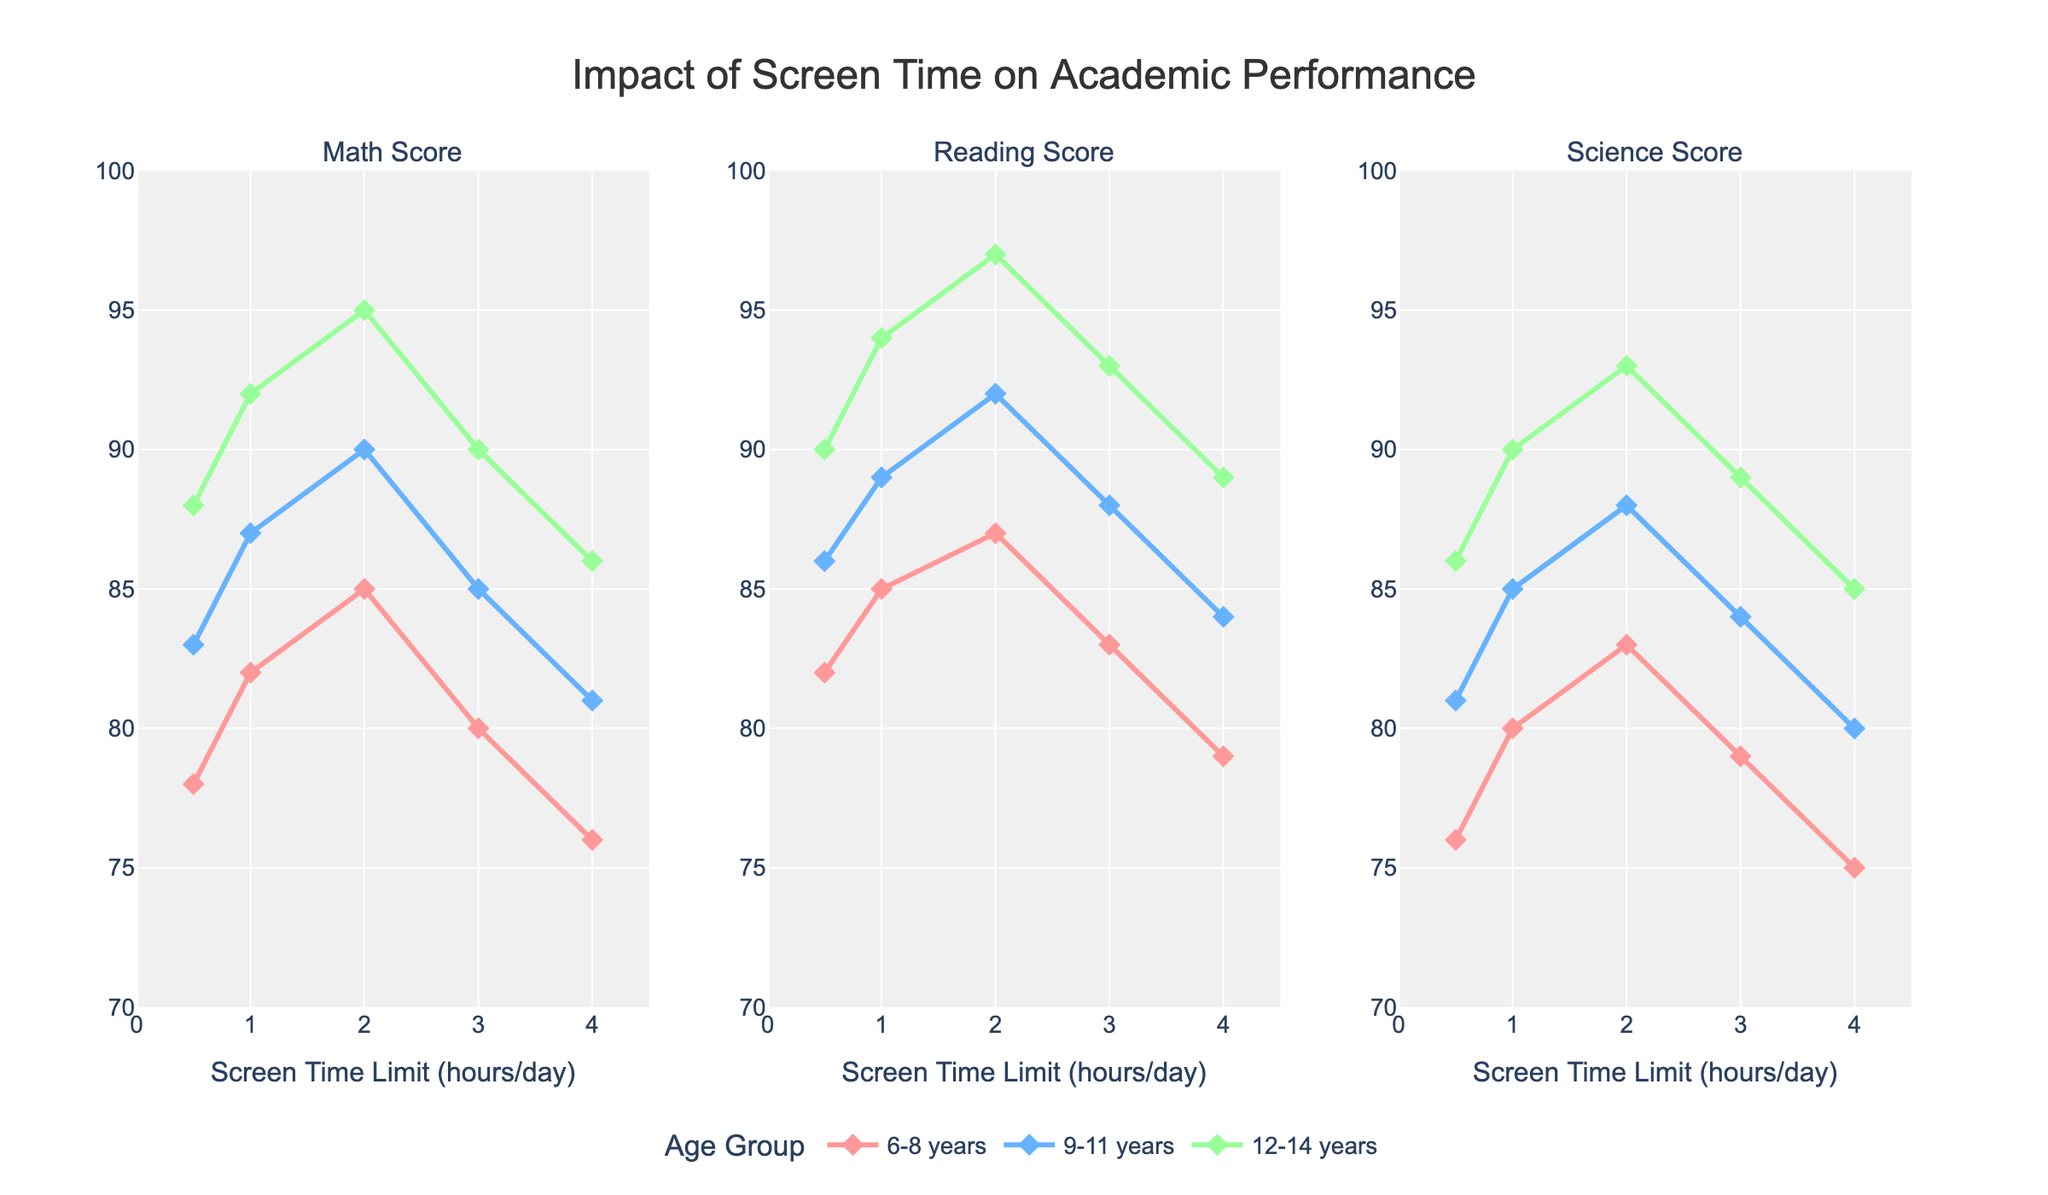What is the title of the figure? The title is located at the top of the figure and is clearly visible. It reads "Impact of Screen Time on Academic Performance."
Answer: Impact of Screen Time on Academic Performance How many age groups are represented in the figure? By observing the legend on the figure, three distinct age groups can be identified.
Answer: Three What trend do you observe in the Math Scores for 6-8-year-olds as screen time increases? By following the line plot for 6-8-year-olds, it can be seen that the Math Scores initially increase with screen time up to 2 hours and then start to decline.
Answer: Initially increase then decline Which age group consistently has the highest scores across all subjects? Looking at the y-values for each age group across the three subplots, the 12-14-year-olds (represented by green) consistently have the highest scores in Math, Reading, and Science.
Answer: 12-14 years What is the Reading Score of 9-11-year-olds at 2 hours of screen time? By looking at the Reading Score subplot, find the data point corresponding to 2 hours for the line representing 9-11-year-olds. The score at this point is 92.
Answer: 92 For which subject and age group does the Screen Time Limit of 4 hours result in the lowest score? By comparing the y-values at 4 hours for each subject and age group, the lowest score of 75 occurs in the Science Score subplot for 6-8-year-olds.
Answer: Science Score for 6-8 years How does the average Math Score for 1 hour of screen time compare across different age groups? Calculate the average Math Scores for 1 hour of screen time for each age group: 82 (6-8 years), 87 (9-11 years), and 92 (12-14 years).
Answer: Increases with age What subject experiences the most significant decline in scores for 4 hours of screen time compared to 2 hours for the 12-14-year-old age group? Compare the decline in scores from 2 hours to 4 hours for each subject. Math: 95 to 86, Reading: 97 to 89, Science: 93 to 85. The largest decline is in Reading Scores.
Answer: Reading Scores For 3 hours of screen time, which age group has the highest Science Score? From the Science Score subplot at 3 hours, observe the y-values: 79 for 6-8 years, 84 for 9-11 years, and 89 for 12-14 years. 12-14 years have the highest score.
Answer: 12-14 years 